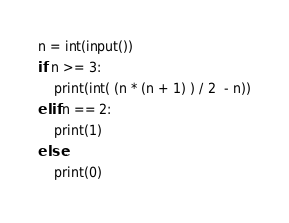<code> <loc_0><loc_0><loc_500><loc_500><_Python_>n = int(input())
if n >= 3:
    print(int( (n * (n + 1) ) / 2  - n))
elif n == 2:
    print(1)
else:
    print(0)</code> 